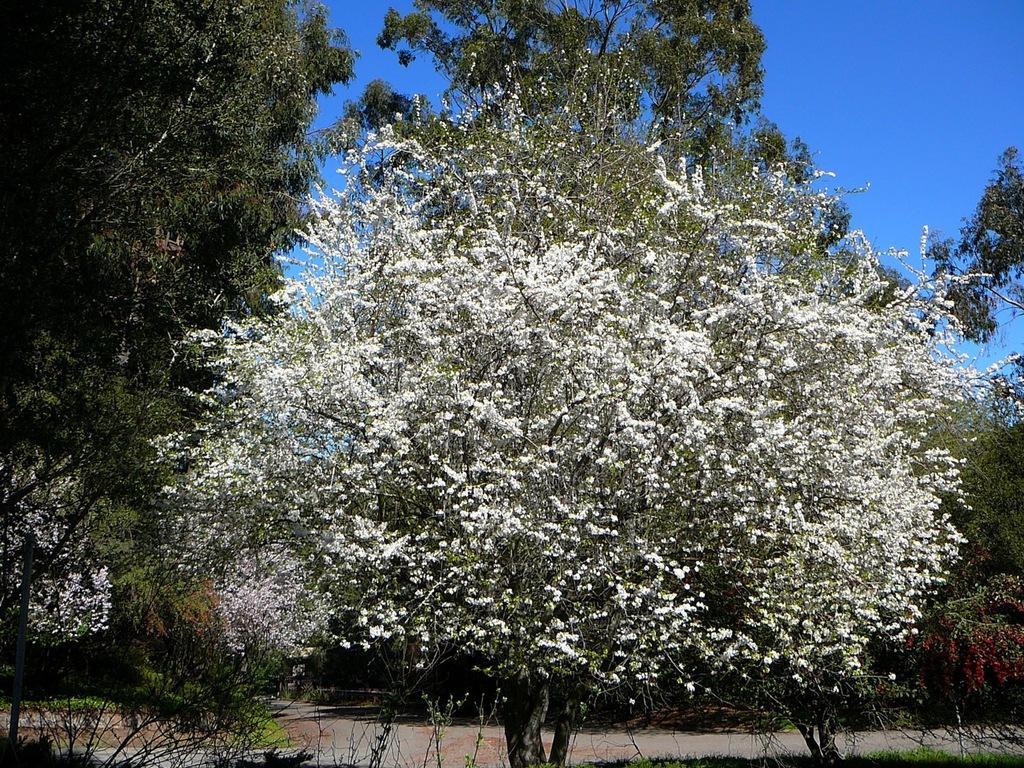In one or two sentences, can you explain what this image depicts? In the image we can see there are lot of trees. 